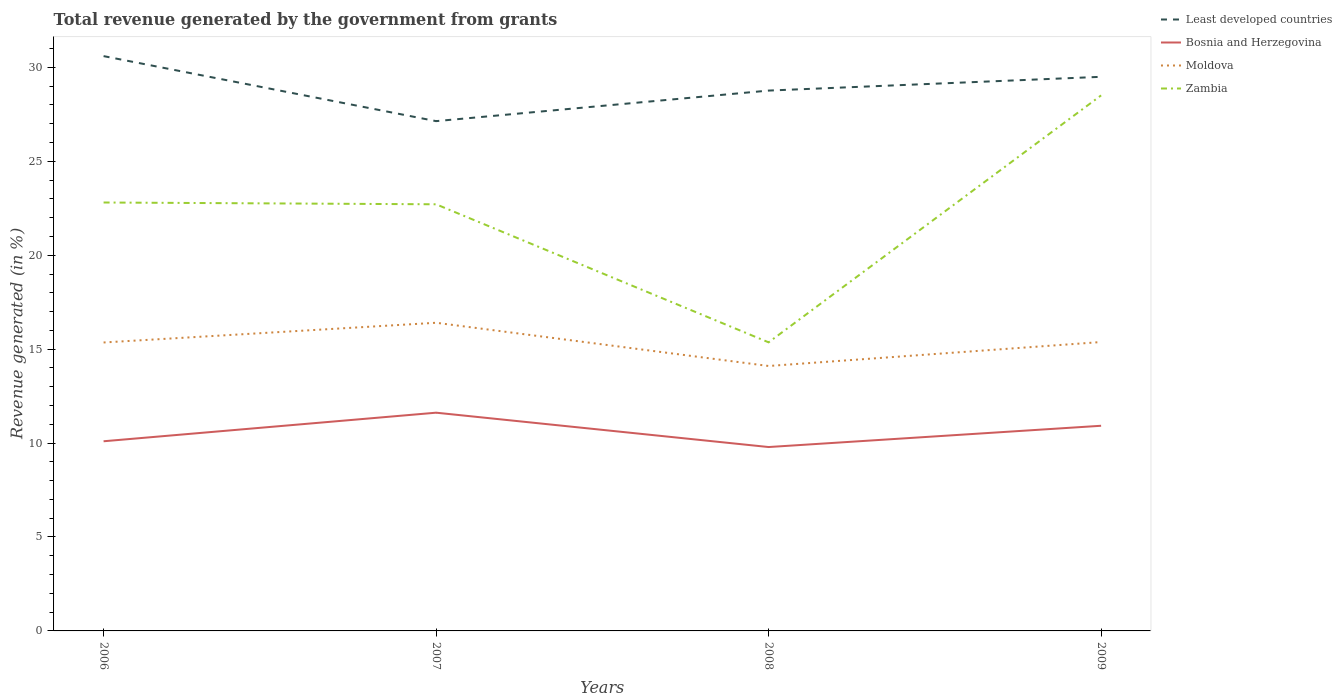How many different coloured lines are there?
Your response must be concise. 4. Across all years, what is the maximum total revenue generated in Bosnia and Herzegovina?
Offer a terse response. 9.79. In which year was the total revenue generated in Bosnia and Herzegovina maximum?
Offer a terse response. 2008. What is the total total revenue generated in Bosnia and Herzegovina in the graph?
Provide a short and direct response. -0.83. What is the difference between the highest and the second highest total revenue generated in Moldova?
Provide a succinct answer. 2.3. What is the difference between the highest and the lowest total revenue generated in Moldova?
Provide a short and direct response. 3. How many lines are there?
Keep it short and to the point. 4. How many years are there in the graph?
Ensure brevity in your answer.  4. What is the difference between two consecutive major ticks on the Y-axis?
Your answer should be compact. 5. Does the graph contain any zero values?
Provide a short and direct response. No. Where does the legend appear in the graph?
Give a very brief answer. Top right. How many legend labels are there?
Provide a short and direct response. 4. How are the legend labels stacked?
Your answer should be compact. Vertical. What is the title of the graph?
Your response must be concise. Total revenue generated by the government from grants. Does "Chad" appear as one of the legend labels in the graph?
Ensure brevity in your answer.  No. What is the label or title of the Y-axis?
Offer a terse response. Revenue generated (in %). What is the Revenue generated (in %) of Least developed countries in 2006?
Keep it short and to the point. 30.6. What is the Revenue generated (in %) of Bosnia and Herzegovina in 2006?
Provide a succinct answer. 10.1. What is the Revenue generated (in %) of Moldova in 2006?
Offer a very short reply. 15.35. What is the Revenue generated (in %) of Zambia in 2006?
Keep it short and to the point. 22.81. What is the Revenue generated (in %) of Least developed countries in 2007?
Your answer should be compact. 27.14. What is the Revenue generated (in %) in Bosnia and Herzegovina in 2007?
Your answer should be very brief. 11.62. What is the Revenue generated (in %) in Moldova in 2007?
Provide a short and direct response. 16.4. What is the Revenue generated (in %) in Zambia in 2007?
Your answer should be compact. 22.71. What is the Revenue generated (in %) in Least developed countries in 2008?
Give a very brief answer. 28.76. What is the Revenue generated (in %) in Bosnia and Herzegovina in 2008?
Make the answer very short. 9.79. What is the Revenue generated (in %) of Moldova in 2008?
Provide a succinct answer. 14.1. What is the Revenue generated (in %) in Zambia in 2008?
Offer a very short reply. 15.36. What is the Revenue generated (in %) in Least developed countries in 2009?
Ensure brevity in your answer.  29.5. What is the Revenue generated (in %) of Bosnia and Herzegovina in 2009?
Offer a very short reply. 10.92. What is the Revenue generated (in %) in Moldova in 2009?
Your answer should be very brief. 15.38. What is the Revenue generated (in %) of Zambia in 2009?
Make the answer very short. 28.51. Across all years, what is the maximum Revenue generated (in %) of Least developed countries?
Your response must be concise. 30.6. Across all years, what is the maximum Revenue generated (in %) in Bosnia and Herzegovina?
Offer a very short reply. 11.62. Across all years, what is the maximum Revenue generated (in %) of Moldova?
Make the answer very short. 16.4. Across all years, what is the maximum Revenue generated (in %) of Zambia?
Your response must be concise. 28.51. Across all years, what is the minimum Revenue generated (in %) of Least developed countries?
Offer a very short reply. 27.14. Across all years, what is the minimum Revenue generated (in %) of Bosnia and Herzegovina?
Give a very brief answer. 9.79. Across all years, what is the minimum Revenue generated (in %) of Moldova?
Offer a terse response. 14.1. Across all years, what is the minimum Revenue generated (in %) of Zambia?
Your response must be concise. 15.36. What is the total Revenue generated (in %) of Least developed countries in the graph?
Offer a terse response. 116. What is the total Revenue generated (in %) in Bosnia and Herzegovina in the graph?
Ensure brevity in your answer.  42.42. What is the total Revenue generated (in %) in Moldova in the graph?
Offer a very short reply. 61.24. What is the total Revenue generated (in %) of Zambia in the graph?
Your answer should be compact. 89.39. What is the difference between the Revenue generated (in %) in Least developed countries in 2006 and that in 2007?
Your answer should be compact. 3.46. What is the difference between the Revenue generated (in %) in Bosnia and Herzegovina in 2006 and that in 2007?
Your answer should be compact. -1.52. What is the difference between the Revenue generated (in %) in Moldova in 2006 and that in 2007?
Keep it short and to the point. -1.05. What is the difference between the Revenue generated (in %) in Zambia in 2006 and that in 2007?
Offer a terse response. 0.1. What is the difference between the Revenue generated (in %) of Least developed countries in 2006 and that in 2008?
Your answer should be very brief. 1.83. What is the difference between the Revenue generated (in %) of Bosnia and Herzegovina in 2006 and that in 2008?
Your answer should be compact. 0.31. What is the difference between the Revenue generated (in %) in Moldova in 2006 and that in 2008?
Make the answer very short. 1.25. What is the difference between the Revenue generated (in %) in Zambia in 2006 and that in 2008?
Provide a succinct answer. 7.44. What is the difference between the Revenue generated (in %) in Least developed countries in 2006 and that in 2009?
Ensure brevity in your answer.  1.1. What is the difference between the Revenue generated (in %) in Bosnia and Herzegovina in 2006 and that in 2009?
Offer a very short reply. -0.83. What is the difference between the Revenue generated (in %) in Moldova in 2006 and that in 2009?
Offer a terse response. -0.02. What is the difference between the Revenue generated (in %) in Zambia in 2006 and that in 2009?
Your answer should be very brief. -5.7. What is the difference between the Revenue generated (in %) of Least developed countries in 2007 and that in 2008?
Give a very brief answer. -1.63. What is the difference between the Revenue generated (in %) in Bosnia and Herzegovina in 2007 and that in 2008?
Offer a terse response. 1.83. What is the difference between the Revenue generated (in %) of Moldova in 2007 and that in 2008?
Provide a short and direct response. 2.3. What is the difference between the Revenue generated (in %) in Zambia in 2007 and that in 2008?
Offer a terse response. 7.35. What is the difference between the Revenue generated (in %) in Least developed countries in 2007 and that in 2009?
Make the answer very short. -2.36. What is the difference between the Revenue generated (in %) in Bosnia and Herzegovina in 2007 and that in 2009?
Your answer should be very brief. 0.7. What is the difference between the Revenue generated (in %) in Moldova in 2007 and that in 2009?
Offer a terse response. 1.03. What is the difference between the Revenue generated (in %) of Zambia in 2007 and that in 2009?
Provide a succinct answer. -5.8. What is the difference between the Revenue generated (in %) of Least developed countries in 2008 and that in 2009?
Your answer should be very brief. -0.73. What is the difference between the Revenue generated (in %) of Bosnia and Herzegovina in 2008 and that in 2009?
Offer a terse response. -1.13. What is the difference between the Revenue generated (in %) of Moldova in 2008 and that in 2009?
Keep it short and to the point. -1.28. What is the difference between the Revenue generated (in %) in Zambia in 2008 and that in 2009?
Your answer should be very brief. -13.15. What is the difference between the Revenue generated (in %) of Least developed countries in 2006 and the Revenue generated (in %) of Bosnia and Herzegovina in 2007?
Give a very brief answer. 18.98. What is the difference between the Revenue generated (in %) in Least developed countries in 2006 and the Revenue generated (in %) in Moldova in 2007?
Provide a short and direct response. 14.19. What is the difference between the Revenue generated (in %) in Least developed countries in 2006 and the Revenue generated (in %) in Zambia in 2007?
Your response must be concise. 7.89. What is the difference between the Revenue generated (in %) in Bosnia and Herzegovina in 2006 and the Revenue generated (in %) in Moldova in 2007?
Offer a terse response. -6.31. What is the difference between the Revenue generated (in %) of Bosnia and Herzegovina in 2006 and the Revenue generated (in %) of Zambia in 2007?
Keep it short and to the point. -12.62. What is the difference between the Revenue generated (in %) in Moldova in 2006 and the Revenue generated (in %) in Zambia in 2007?
Make the answer very short. -7.36. What is the difference between the Revenue generated (in %) in Least developed countries in 2006 and the Revenue generated (in %) in Bosnia and Herzegovina in 2008?
Offer a very short reply. 20.81. What is the difference between the Revenue generated (in %) of Least developed countries in 2006 and the Revenue generated (in %) of Moldova in 2008?
Your answer should be compact. 16.5. What is the difference between the Revenue generated (in %) of Least developed countries in 2006 and the Revenue generated (in %) of Zambia in 2008?
Keep it short and to the point. 15.24. What is the difference between the Revenue generated (in %) in Bosnia and Herzegovina in 2006 and the Revenue generated (in %) in Moldova in 2008?
Make the answer very short. -4.01. What is the difference between the Revenue generated (in %) of Bosnia and Herzegovina in 2006 and the Revenue generated (in %) of Zambia in 2008?
Offer a terse response. -5.27. What is the difference between the Revenue generated (in %) of Moldova in 2006 and the Revenue generated (in %) of Zambia in 2008?
Make the answer very short. -0.01. What is the difference between the Revenue generated (in %) of Least developed countries in 2006 and the Revenue generated (in %) of Bosnia and Herzegovina in 2009?
Your response must be concise. 19.68. What is the difference between the Revenue generated (in %) of Least developed countries in 2006 and the Revenue generated (in %) of Moldova in 2009?
Keep it short and to the point. 15.22. What is the difference between the Revenue generated (in %) of Least developed countries in 2006 and the Revenue generated (in %) of Zambia in 2009?
Offer a very short reply. 2.09. What is the difference between the Revenue generated (in %) in Bosnia and Herzegovina in 2006 and the Revenue generated (in %) in Moldova in 2009?
Your answer should be very brief. -5.28. What is the difference between the Revenue generated (in %) of Bosnia and Herzegovina in 2006 and the Revenue generated (in %) of Zambia in 2009?
Provide a short and direct response. -18.41. What is the difference between the Revenue generated (in %) in Moldova in 2006 and the Revenue generated (in %) in Zambia in 2009?
Your answer should be very brief. -13.15. What is the difference between the Revenue generated (in %) of Least developed countries in 2007 and the Revenue generated (in %) of Bosnia and Herzegovina in 2008?
Provide a short and direct response. 17.35. What is the difference between the Revenue generated (in %) in Least developed countries in 2007 and the Revenue generated (in %) in Moldova in 2008?
Offer a terse response. 13.03. What is the difference between the Revenue generated (in %) in Least developed countries in 2007 and the Revenue generated (in %) in Zambia in 2008?
Ensure brevity in your answer.  11.78. What is the difference between the Revenue generated (in %) in Bosnia and Herzegovina in 2007 and the Revenue generated (in %) in Moldova in 2008?
Provide a short and direct response. -2.49. What is the difference between the Revenue generated (in %) in Bosnia and Herzegovina in 2007 and the Revenue generated (in %) in Zambia in 2008?
Offer a very short reply. -3.75. What is the difference between the Revenue generated (in %) of Moldova in 2007 and the Revenue generated (in %) of Zambia in 2008?
Offer a very short reply. 1.04. What is the difference between the Revenue generated (in %) of Least developed countries in 2007 and the Revenue generated (in %) of Bosnia and Herzegovina in 2009?
Keep it short and to the point. 16.22. What is the difference between the Revenue generated (in %) in Least developed countries in 2007 and the Revenue generated (in %) in Moldova in 2009?
Offer a very short reply. 11.76. What is the difference between the Revenue generated (in %) of Least developed countries in 2007 and the Revenue generated (in %) of Zambia in 2009?
Provide a succinct answer. -1.37. What is the difference between the Revenue generated (in %) of Bosnia and Herzegovina in 2007 and the Revenue generated (in %) of Moldova in 2009?
Give a very brief answer. -3.76. What is the difference between the Revenue generated (in %) in Bosnia and Herzegovina in 2007 and the Revenue generated (in %) in Zambia in 2009?
Keep it short and to the point. -16.89. What is the difference between the Revenue generated (in %) of Moldova in 2007 and the Revenue generated (in %) of Zambia in 2009?
Offer a very short reply. -12.1. What is the difference between the Revenue generated (in %) in Least developed countries in 2008 and the Revenue generated (in %) in Bosnia and Herzegovina in 2009?
Make the answer very short. 17.84. What is the difference between the Revenue generated (in %) of Least developed countries in 2008 and the Revenue generated (in %) of Moldova in 2009?
Keep it short and to the point. 13.39. What is the difference between the Revenue generated (in %) in Least developed countries in 2008 and the Revenue generated (in %) in Zambia in 2009?
Your answer should be compact. 0.26. What is the difference between the Revenue generated (in %) in Bosnia and Herzegovina in 2008 and the Revenue generated (in %) in Moldova in 2009?
Your answer should be compact. -5.59. What is the difference between the Revenue generated (in %) in Bosnia and Herzegovina in 2008 and the Revenue generated (in %) in Zambia in 2009?
Keep it short and to the point. -18.72. What is the difference between the Revenue generated (in %) of Moldova in 2008 and the Revenue generated (in %) of Zambia in 2009?
Your answer should be compact. -14.4. What is the average Revenue generated (in %) in Least developed countries per year?
Ensure brevity in your answer.  29. What is the average Revenue generated (in %) in Bosnia and Herzegovina per year?
Make the answer very short. 10.61. What is the average Revenue generated (in %) in Moldova per year?
Keep it short and to the point. 15.31. What is the average Revenue generated (in %) in Zambia per year?
Offer a very short reply. 22.35. In the year 2006, what is the difference between the Revenue generated (in %) in Least developed countries and Revenue generated (in %) in Bosnia and Herzegovina?
Your answer should be very brief. 20.5. In the year 2006, what is the difference between the Revenue generated (in %) in Least developed countries and Revenue generated (in %) in Moldova?
Provide a succinct answer. 15.24. In the year 2006, what is the difference between the Revenue generated (in %) in Least developed countries and Revenue generated (in %) in Zambia?
Your response must be concise. 7.79. In the year 2006, what is the difference between the Revenue generated (in %) in Bosnia and Herzegovina and Revenue generated (in %) in Moldova?
Provide a short and direct response. -5.26. In the year 2006, what is the difference between the Revenue generated (in %) in Bosnia and Herzegovina and Revenue generated (in %) in Zambia?
Provide a succinct answer. -12.71. In the year 2006, what is the difference between the Revenue generated (in %) in Moldova and Revenue generated (in %) in Zambia?
Your answer should be compact. -7.45. In the year 2007, what is the difference between the Revenue generated (in %) of Least developed countries and Revenue generated (in %) of Bosnia and Herzegovina?
Provide a short and direct response. 15.52. In the year 2007, what is the difference between the Revenue generated (in %) in Least developed countries and Revenue generated (in %) in Moldova?
Make the answer very short. 10.73. In the year 2007, what is the difference between the Revenue generated (in %) in Least developed countries and Revenue generated (in %) in Zambia?
Make the answer very short. 4.43. In the year 2007, what is the difference between the Revenue generated (in %) in Bosnia and Herzegovina and Revenue generated (in %) in Moldova?
Offer a very short reply. -4.79. In the year 2007, what is the difference between the Revenue generated (in %) in Bosnia and Herzegovina and Revenue generated (in %) in Zambia?
Your response must be concise. -11.09. In the year 2007, what is the difference between the Revenue generated (in %) in Moldova and Revenue generated (in %) in Zambia?
Ensure brevity in your answer.  -6.31. In the year 2008, what is the difference between the Revenue generated (in %) in Least developed countries and Revenue generated (in %) in Bosnia and Herzegovina?
Offer a terse response. 18.98. In the year 2008, what is the difference between the Revenue generated (in %) of Least developed countries and Revenue generated (in %) of Moldova?
Your answer should be compact. 14.66. In the year 2008, what is the difference between the Revenue generated (in %) of Least developed countries and Revenue generated (in %) of Zambia?
Make the answer very short. 13.4. In the year 2008, what is the difference between the Revenue generated (in %) of Bosnia and Herzegovina and Revenue generated (in %) of Moldova?
Keep it short and to the point. -4.31. In the year 2008, what is the difference between the Revenue generated (in %) of Bosnia and Herzegovina and Revenue generated (in %) of Zambia?
Offer a very short reply. -5.57. In the year 2008, what is the difference between the Revenue generated (in %) in Moldova and Revenue generated (in %) in Zambia?
Give a very brief answer. -1.26. In the year 2009, what is the difference between the Revenue generated (in %) of Least developed countries and Revenue generated (in %) of Bosnia and Herzegovina?
Make the answer very short. 18.58. In the year 2009, what is the difference between the Revenue generated (in %) of Least developed countries and Revenue generated (in %) of Moldova?
Ensure brevity in your answer.  14.12. In the year 2009, what is the difference between the Revenue generated (in %) in Least developed countries and Revenue generated (in %) in Zambia?
Provide a short and direct response. 0.99. In the year 2009, what is the difference between the Revenue generated (in %) of Bosnia and Herzegovina and Revenue generated (in %) of Moldova?
Provide a short and direct response. -4.46. In the year 2009, what is the difference between the Revenue generated (in %) in Bosnia and Herzegovina and Revenue generated (in %) in Zambia?
Keep it short and to the point. -17.59. In the year 2009, what is the difference between the Revenue generated (in %) of Moldova and Revenue generated (in %) of Zambia?
Your response must be concise. -13.13. What is the ratio of the Revenue generated (in %) in Least developed countries in 2006 to that in 2007?
Your answer should be compact. 1.13. What is the ratio of the Revenue generated (in %) of Bosnia and Herzegovina in 2006 to that in 2007?
Your response must be concise. 0.87. What is the ratio of the Revenue generated (in %) of Moldova in 2006 to that in 2007?
Ensure brevity in your answer.  0.94. What is the ratio of the Revenue generated (in %) of Least developed countries in 2006 to that in 2008?
Offer a very short reply. 1.06. What is the ratio of the Revenue generated (in %) in Bosnia and Herzegovina in 2006 to that in 2008?
Your response must be concise. 1.03. What is the ratio of the Revenue generated (in %) in Moldova in 2006 to that in 2008?
Your answer should be compact. 1.09. What is the ratio of the Revenue generated (in %) of Zambia in 2006 to that in 2008?
Ensure brevity in your answer.  1.48. What is the ratio of the Revenue generated (in %) in Least developed countries in 2006 to that in 2009?
Provide a short and direct response. 1.04. What is the ratio of the Revenue generated (in %) in Bosnia and Herzegovina in 2006 to that in 2009?
Give a very brief answer. 0.92. What is the ratio of the Revenue generated (in %) of Moldova in 2006 to that in 2009?
Your answer should be compact. 1. What is the ratio of the Revenue generated (in %) in Zambia in 2006 to that in 2009?
Provide a short and direct response. 0.8. What is the ratio of the Revenue generated (in %) of Least developed countries in 2007 to that in 2008?
Ensure brevity in your answer.  0.94. What is the ratio of the Revenue generated (in %) in Bosnia and Herzegovina in 2007 to that in 2008?
Your answer should be compact. 1.19. What is the ratio of the Revenue generated (in %) in Moldova in 2007 to that in 2008?
Ensure brevity in your answer.  1.16. What is the ratio of the Revenue generated (in %) in Zambia in 2007 to that in 2008?
Give a very brief answer. 1.48. What is the ratio of the Revenue generated (in %) of Bosnia and Herzegovina in 2007 to that in 2009?
Make the answer very short. 1.06. What is the ratio of the Revenue generated (in %) in Moldova in 2007 to that in 2009?
Provide a short and direct response. 1.07. What is the ratio of the Revenue generated (in %) in Zambia in 2007 to that in 2009?
Give a very brief answer. 0.8. What is the ratio of the Revenue generated (in %) in Least developed countries in 2008 to that in 2009?
Give a very brief answer. 0.98. What is the ratio of the Revenue generated (in %) of Bosnia and Herzegovina in 2008 to that in 2009?
Ensure brevity in your answer.  0.9. What is the ratio of the Revenue generated (in %) in Moldova in 2008 to that in 2009?
Your answer should be very brief. 0.92. What is the ratio of the Revenue generated (in %) in Zambia in 2008 to that in 2009?
Keep it short and to the point. 0.54. What is the difference between the highest and the second highest Revenue generated (in %) in Least developed countries?
Provide a succinct answer. 1.1. What is the difference between the highest and the second highest Revenue generated (in %) in Bosnia and Herzegovina?
Your response must be concise. 0.7. What is the difference between the highest and the second highest Revenue generated (in %) of Moldova?
Make the answer very short. 1.03. What is the difference between the highest and the second highest Revenue generated (in %) in Zambia?
Keep it short and to the point. 5.7. What is the difference between the highest and the lowest Revenue generated (in %) in Least developed countries?
Make the answer very short. 3.46. What is the difference between the highest and the lowest Revenue generated (in %) in Bosnia and Herzegovina?
Ensure brevity in your answer.  1.83. What is the difference between the highest and the lowest Revenue generated (in %) of Moldova?
Your answer should be very brief. 2.3. What is the difference between the highest and the lowest Revenue generated (in %) of Zambia?
Give a very brief answer. 13.15. 